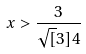<formula> <loc_0><loc_0><loc_500><loc_500>x > \frac { 3 } { \sqrt { [ } 3 ] { 4 } }</formula> 